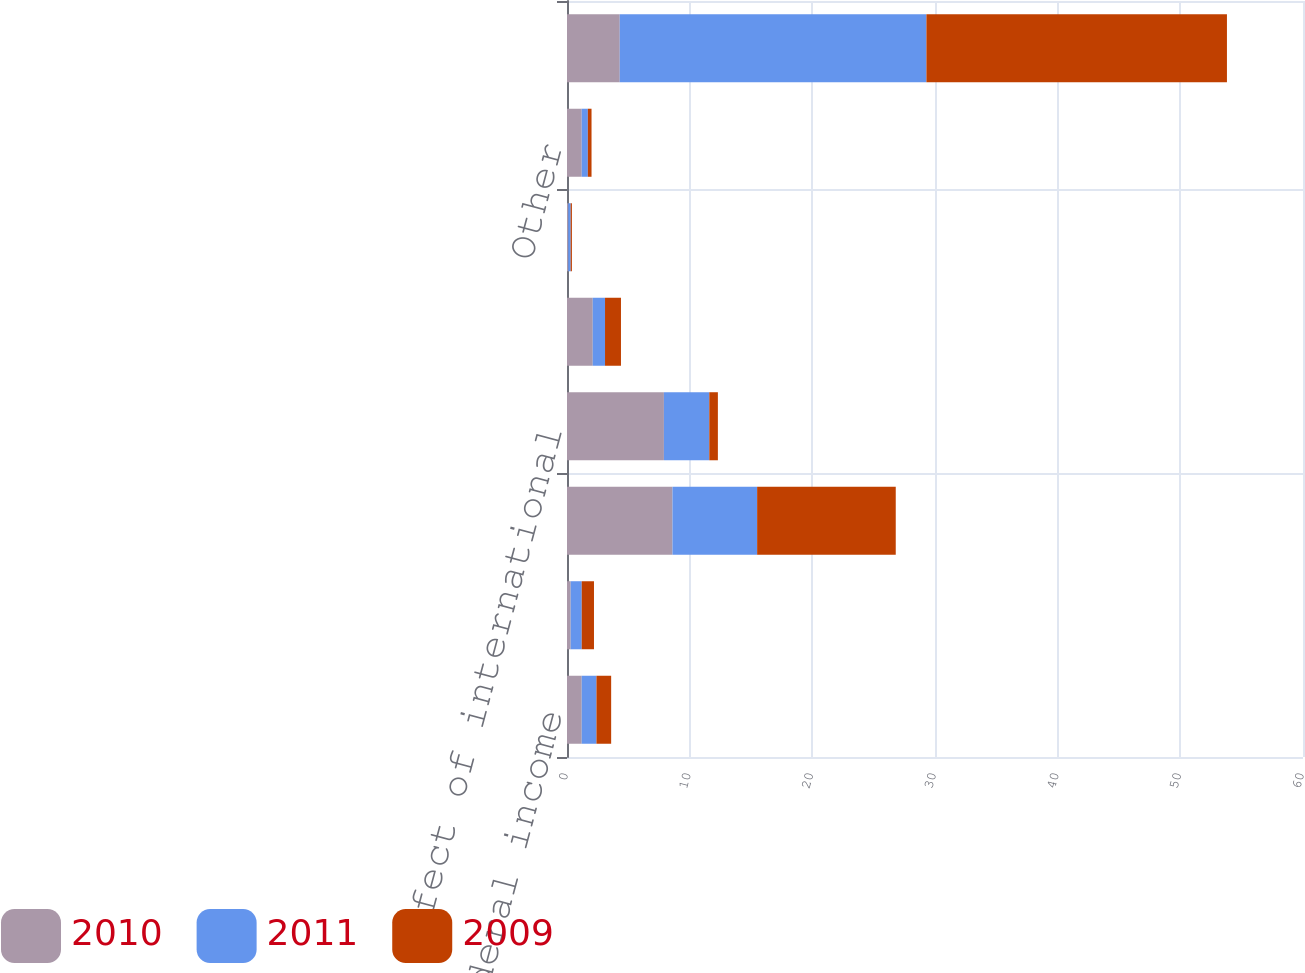<chart> <loc_0><loc_0><loc_500><loc_500><stacked_bar_chart><ecel><fcel>Statutory U S federal income<fcel>State income taxes net of<fcel>Federal benefit of R&D and<fcel>Tax effect of international<fcel>Net effect of tax audit<fcel>Federal tax on unremitted<fcel>Other<fcel>Effective income tax rate on<nl><fcel>2010<fcel>1.2<fcel>0.3<fcel>8.6<fcel>7.9<fcel>2.1<fcel>0.1<fcel>1.2<fcel>4.3<nl><fcel>2011<fcel>1.2<fcel>0.9<fcel>6.9<fcel>3.7<fcel>1<fcel>0.2<fcel>0.5<fcel>25<nl><fcel>2009<fcel>1.2<fcel>1<fcel>11.3<fcel>0.7<fcel>1.3<fcel>0.1<fcel>0.3<fcel>24.5<nl></chart> 